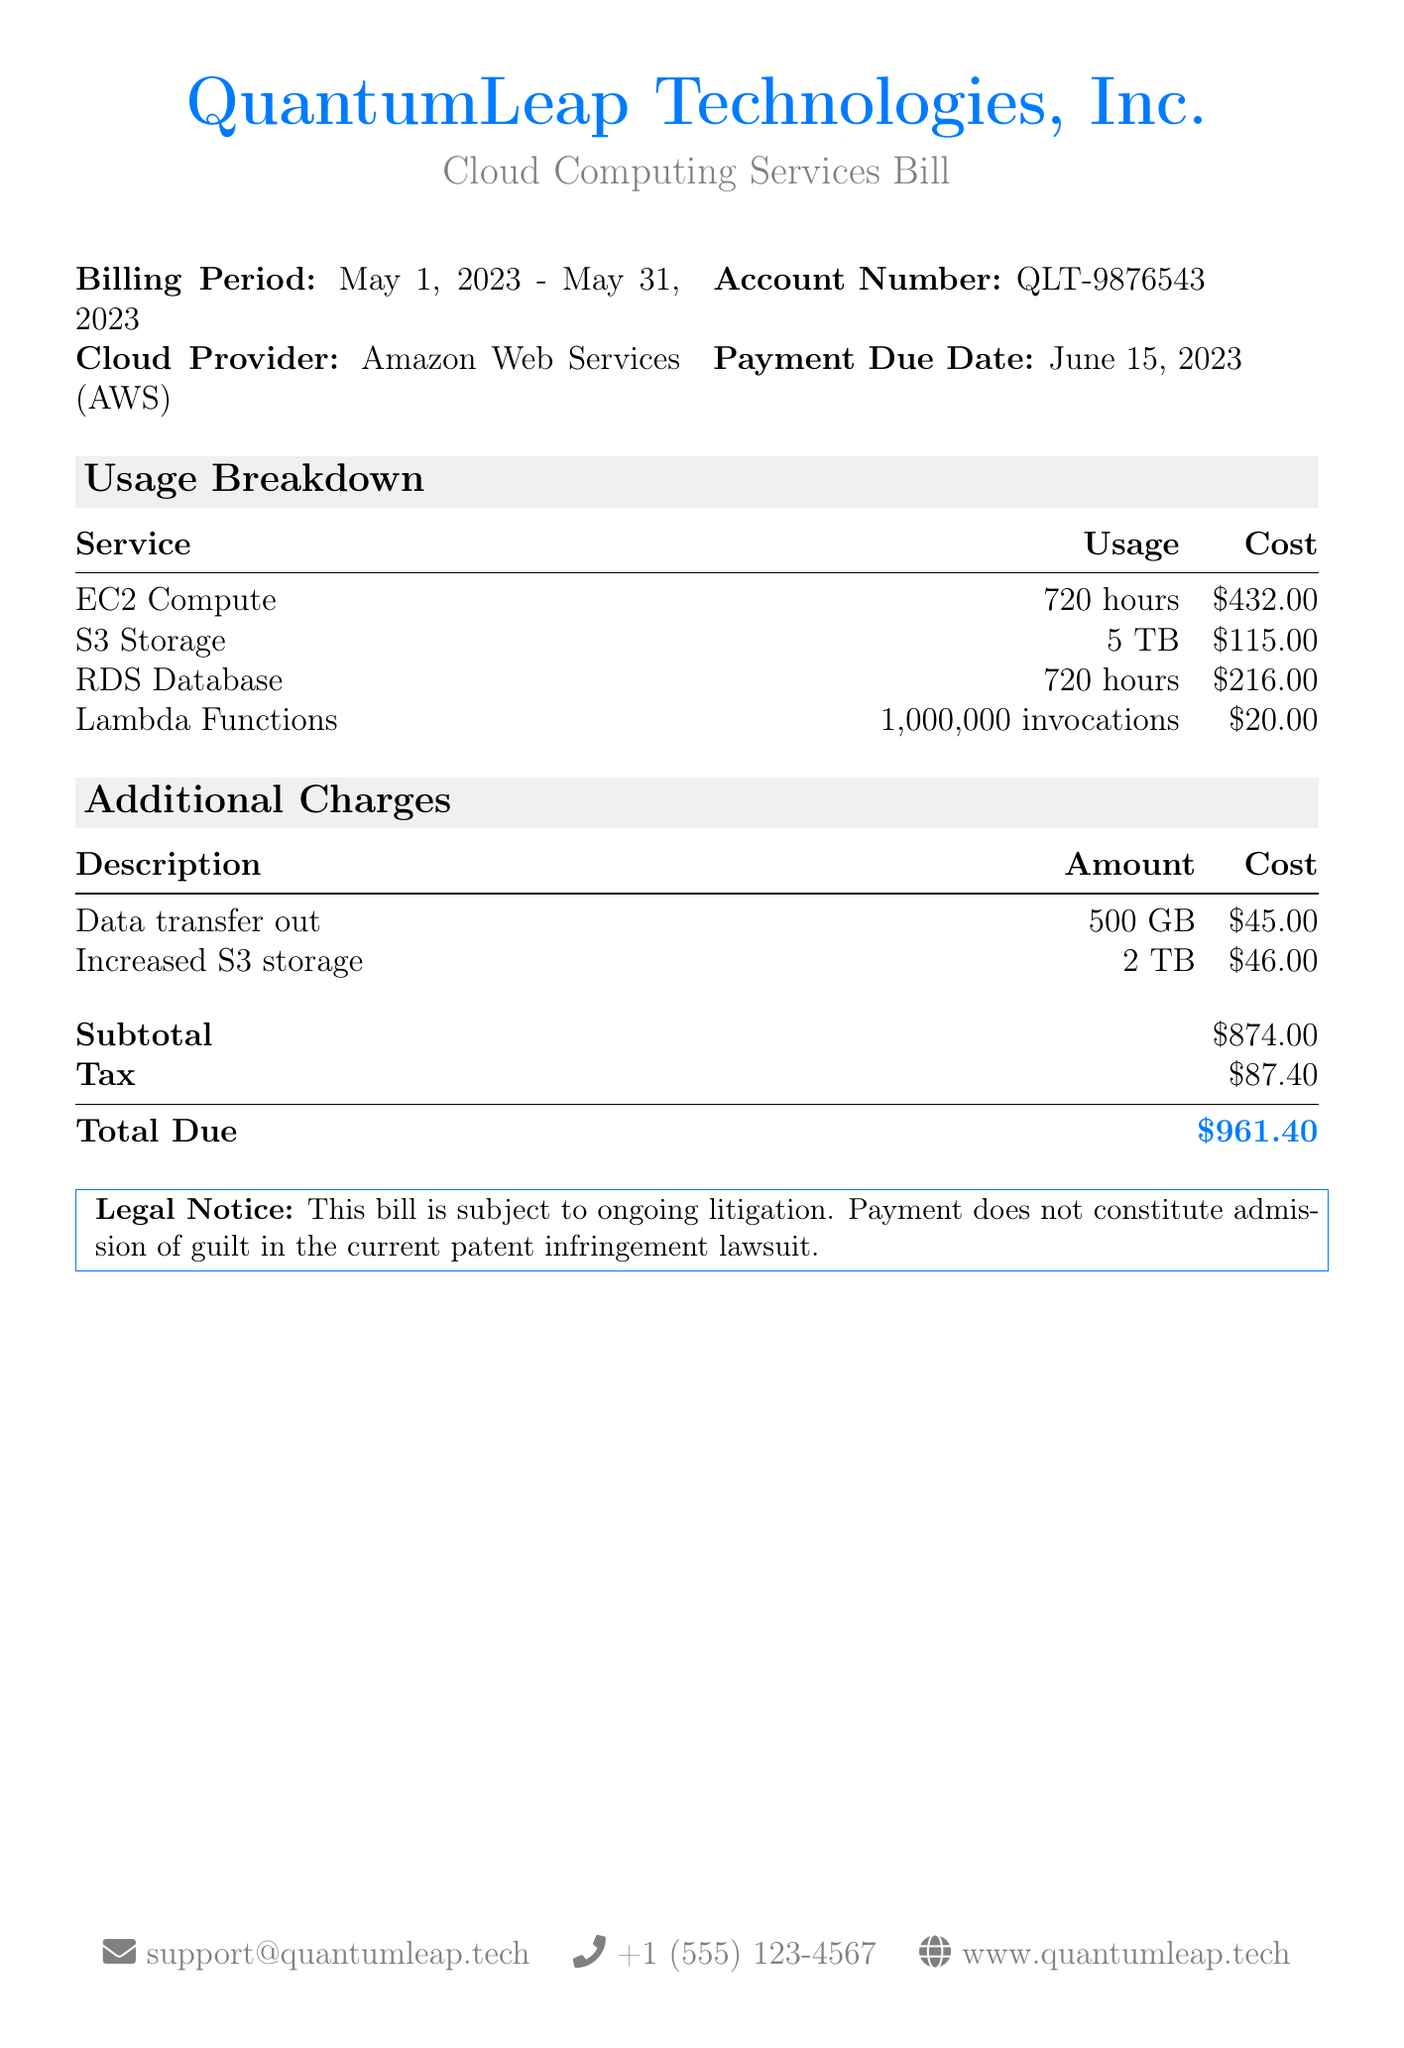What is the billing period? The billing period is indicated in the document as May 1, 2023 to May 31, 2023.
Answer: May 1, 2023 - May 31, 2023 What is the total due amount? The total due amount is clearly stated at the bottom of the document.
Answer: $961.40 How much was charged for S3 Storage? The cost for S3 Storage is listed in the usage breakdown section of the document.
Answer: $115.00 What is the cost of increased S3 storage? The charge for increased S3 storage is detailed under additional charges in the document.
Answer: $46.00 What is the account number? The account number is specified in the document for billing reference.
Answer: QLT-9876543 How much tax is included in the total? The tax amount is provided in the total breakdown of the bill.
Answer: $87.40 What cloud provider is mentioned in the bill? The cloud provider name is listed at the top of the document.
Answer: Amazon Web Services (AWS) What was the total usage time for EC2 Compute? The total usage time for EC2 Compute is found in the usage breakdown section.
Answer: 720 hours What legal notice is included in the bill? The legal notice is stated at the bottom of the document, informing about ongoing litigation.
Answer: This bill is subject to ongoing litigation 